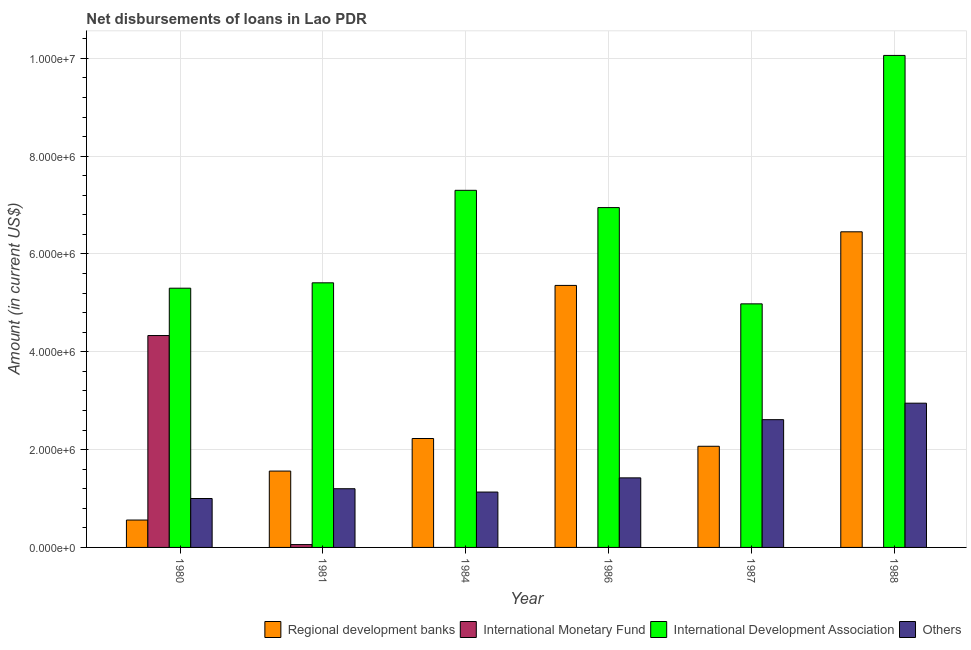In how many cases, is the number of bars for a given year not equal to the number of legend labels?
Your answer should be very brief. 4. What is the amount of loan disimbursed by international monetary fund in 1988?
Offer a very short reply. 0. Across all years, what is the maximum amount of loan disimbursed by regional development banks?
Offer a very short reply. 6.45e+06. Across all years, what is the minimum amount of loan disimbursed by other organisations?
Your response must be concise. 1.00e+06. In which year was the amount of loan disimbursed by international development association maximum?
Your response must be concise. 1988. What is the total amount of loan disimbursed by other organisations in the graph?
Give a very brief answer. 1.03e+07. What is the difference between the amount of loan disimbursed by regional development banks in 1981 and that in 1987?
Keep it short and to the point. -5.07e+05. What is the difference between the amount of loan disimbursed by regional development banks in 1986 and the amount of loan disimbursed by international development association in 1987?
Give a very brief answer. 3.29e+06. What is the average amount of loan disimbursed by regional development banks per year?
Offer a very short reply. 3.04e+06. In the year 1987, what is the difference between the amount of loan disimbursed by regional development banks and amount of loan disimbursed by other organisations?
Offer a terse response. 0. In how many years, is the amount of loan disimbursed by international monetary fund greater than 7600000 US$?
Give a very brief answer. 0. What is the ratio of the amount of loan disimbursed by regional development banks in 1981 to that in 1987?
Keep it short and to the point. 0.75. Is the amount of loan disimbursed by other organisations in 1987 less than that in 1988?
Keep it short and to the point. Yes. What is the difference between the highest and the second highest amount of loan disimbursed by other organisations?
Offer a terse response. 3.37e+05. What is the difference between the highest and the lowest amount of loan disimbursed by international monetary fund?
Your answer should be compact. 4.33e+06. In how many years, is the amount of loan disimbursed by international monetary fund greater than the average amount of loan disimbursed by international monetary fund taken over all years?
Your answer should be very brief. 1. How many bars are there?
Offer a terse response. 20. How many years are there in the graph?
Make the answer very short. 6. What is the difference between two consecutive major ticks on the Y-axis?
Your answer should be very brief. 2.00e+06. Are the values on the major ticks of Y-axis written in scientific E-notation?
Your answer should be compact. Yes. How many legend labels are there?
Keep it short and to the point. 4. How are the legend labels stacked?
Provide a short and direct response. Horizontal. What is the title of the graph?
Make the answer very short. Net disbursements of loans in Lao PDR. Does "Arable land" appear as one of the legend labels in the graph?
Give a very brief answer. No. What is the Amount (in current US$) of Regional development banks in 1980?
Ensure brevity in your answer.  5.60e+05. What is the Amount (in current US$) in International Monetary Fund in 1980?
Make the answer very short. 4.33e+06. What is the Amount (in current US$) in International Development Association in 1980?
Provide a short and direct response. 5.30e+06. What is the Amount (in current US$) in Others in 1980?
Offer a terse response. 1.00e+06. What is the Amount (in current US$) in Regional development banks in 1981?
Give a very brief answer. 1.56e+06. What is the Amount (in current US$) of International Monetary Fund in 1981?
Your answer should be very brief. 5.80e+04. What is the Amount (in current US$) of International Development Association in 1981?
Make the answer very short. 5.41e+06. What is the Amount (in current US$) of Others in 1981?
Ensure brevity in your answer.  1.20e+06. What is the Amount (in current US$) of Regional development banks in 1984?
Provide a short and direct response. 2.23e+06. What is the Amount (in current US$) in International Development Association in 1984?
Make the answer very short. 7.30e+06. What is the Amount (in current US$) in Others in 1984?
Provide a succinct answer. 1.13e+06. What is the Amount (in current US$) of Regional development banks in 1986?
Provide a short and direct response. 5.36e+06. What is the Amount (in current US$) of International Development Association in 1986?
Your response must be concise. 6.95e+06. What is the Amount (in current US$) of Others in 1986?
Offer a terse response. 1.42e+06. What is the Amount (in current US$) in Regional development banks in 1987?
Your answer should be very brief. 2.07e+06. What is the Amount (in current US$) in International Development Association in 1987?
Your answer should be compact. 4.98e+06. What is the Amount (in current US$) in Others in 1987?
Keep it short and to the point. 2.61e+06. What is the Amount (in current US$) of Regional development banks in 1988?
Give a very brief answer. 6.45e+06. What is the Amount (in current US$) of International Development Association in 1988?
Keep it short and to the point. 1.01e+07. What is the Amount (in current US$) in Others in 1988?
Keep it short and to the point. 2.95e+06. Across all years, what is the maximum Amount (in current US$) of Regional development banks?
Ensure brevity in your answer.  6.45e+06. Across all years, what is the maximum Amount (in current US$) of International Monetary Fund?
Your response must be concise. 4.33e+06. Across all years, what is the maximum Amount (in current US$) of International Development Association?
Offer a terse response. 1.01e+07. Across all years, what is the maximum Amount (in current US$) of Others?
Keep it short and to the point. 2.95e+06. Across all years, what is the minimum Amount (in current US$) of Regional development banks?
Your answer should be compact. 5.60e+05. Across all years, what is the minimum Amount (in current US$) in International Monetary Fund?
Your response must be concise. 0. Across all years, what is the minimum Amount (in current US$) in International Development Association?
Your answer should be compact. 4.98e+06. Across all years, what is the minimum Amount (in current US$) of Others?
Your response must be concise. 1.00e+06. What is the total Amount (in current US$) in Regional development banks in the graph?
Ensure brevity in your answer.  1.82e+07. What is the total Amount (in current US$) in International Monetary Fund in the graph?
Provide a short and direct response. 4.39e+06. What is the total Amount (in current US$) of International Development Association in the graph?
Offer a terse response. 4.00e+07. What is the total Amount (in current US$) of Others in the graph?
Your response must be concise. 1.03e+07. What is the difference between the Amount (in current US$) in Regional development banks in 1980 and that in 1981?
Keep it short and to the point. -1.00e+06. What is the difference between the Amount (in current US$) in International Monetary Fund in 1980 and that in 1981?
Offer a very short reply. 4.27e+06. What is the difference between the Amount (in current US$) of Regional development banks in 1980 and that in 1984?
Your response must be concise. -1.67e+06. What is the difference between the Amount (in current US$) in International Development Association in 1980 and that in 1984?
Make the answer very short. -2.00e+06. What is the difference between the Amount (in current US$) of Others in 1980 and that in 1984?
Offer a terse response. -1.32e+05. What is the difference between the Amount (in current US$) of Regional development banks in 1980 and that in 1986?
Your answer should be compact. -4.80e+06. What is the difference between the Amount (in current US$) of International Development Association in 1980 and that in 1986?
Provide a succinct answer. -1.65e+06. What is the difference between the Amount (in current US$) in Others in 1980 and that in 1986?
Provide a short and direct response. -4.22e+05. What is the difference between the Amount (in current US$) in Regional development banks in 1980 and that in 1987?
Give a very brief answer. -1.51e+06. What is the difference between the Amount (in current US$) of Others in 1980 and that in 1987?
Provide a short and direct response. -1.61e+06. What is the difference between the Amount (in current US$) in Regional development banks in 1980 and that in 1988?
Provide a short and direct response. -5.89e+06. What is the difference between the Amount (in current US$) of International Development Association in 1980 and that in 1988?
Your response must be concise. -4.76e+06. What is the difference between the Amount (in current US$) in Others in 1980 and that in 1988?
Provide a succinct answer. -1.95e+06. What is the difference between the Amount (in current US$) in Regional development banks in 1981 and that in 1984?
Your answer should be very brief. -6.66e+05. What is the difference between the Amount (in current US$) in International Development Association in 1981 and that in 1984?
Offer a terse response. -1.89e+06. What is the difference between the Amount (in current US$) in Others in 1981 and that in 1984?
Ensure brevity in your answer.  6.80e+04. What is the difference between the Amount (in current US$) in Regional development banks in 1981 and that in 1986?
Ensure brevity in your answer.  -3.80e+06. What is the difference between the Amount (in current US$) of International Development Association in 1981 and that in 1986?
Your answer should be compact. -1.54e+06. What is the difference between the Amount (in current US$) of Others in 1981 and that in 1986?
Your response must be concise. -2.22e+05. What is the difference between the Amount (in current US$) of Regional development banks in 1981 and that in 1987?
Ensure brevity in your answer.  -5.07e+05. What is the difference between the Amount (in current US$) of International Development Association in 1981 and that in 1987?
Your answer should be compact. 4.30e+05. What is the difference between the Amount (in current US$) in Others in 1981 and that in 1987?
Offer a very short reply. -1.41e+06. What is the difference between the Amount (in current US$) in Regional development banks in 1981 and that in 1988?
Make the answer very short. -4.89e+06. What is the difference between the Amount (in current US$) in International Development Association in 1981 and that in 1988?
Your response must be concise. -4.65e+06. What is the difference between the Amount (in current US$) in Others in 1981 and that in 1988?
Your answer should be compact. -1.75e+06. What is the difference between the Amount (in current US$) of Regional development banks in 1984 and that in 1986?
Provide a short and direct response. -3.13e+06. What is the difference between the Amount (in current US$) in International Development Association in 1984 and that in 1986?
Offer a terse response. 3.53e+05. What is the difference between the Amount (in current US$) in Others in 1984 and that in 1986?
Your answer should be very brief. -2.90e+05. What is the difference between the Amount (in current US$) of Regional development banks in 1984 and that in 1987?
Keep it short and to the point. 1.59e+05. What is the difference between the Amount (in current US$) in International Development Association in 1984 and that in 1987?
Ensure brevity in your answer.  2.32e+06. What is the difference between the Amount (in current US$) in Others in 1984 and that in 1987?
Give a very brief answer. -1.48e+06. What is the difference between the Amount (in current US$) of Regional development banks in 1984 and that in 1988?
Provide a short and direct response. -4.23e+06. What is the difference between the Amount (in current US$) of International Development Association in 1984 and that in 1988?
Your response must be concise. -2.76e+06. What is the difference between the Amount (in current US$) of Others in 1984 and that in 1988?
Provide a succinct answer. -1.82e+06. What is the difference between the Amount (in current US$) in Regional development banks in 1986 and that in 1987?
Your response must be concise. 3.29e+06. What is the difference between the Amount (in current US$) of International Development Association in 1986 and that in 1987?
Ensure brevity in your answer.  1.97e+06. What is the difference between the Amount (in current US$) of Others in 1986 and that in 1987?
Keep it short and to the point. -1.19e+06. What is the difference between the Amount (in current US$) in Regional development banks in 1986 and that in 1988?
Provide a short and direct response. -1.10e+06. What is the difference between the Amount (in current US$) in International Development Association in 1986 and that in 1988?
Make the answer very short. -3.11e+06. What is the difference between the Amount (in current US$) of Others in 1986 and that in 1988?
Give a very brief answer. -1.53e+06. What is the difference between the Amount (in current US$) in Regional development banks in 1987 and that in 1988?
Offer a terse response. -4.38e+06. What is the difference between the Amount (in current US$) of International Development Association in 1987 and that in 1988?
Ensure brevity in your answer.  -5.08e+06. What is the difference between the Amount (in current US$) in Others in 1987 and that in 1988?
Offer a terse response. -3.37e+05. What is the difference between the Amount (in current US$) of Regional development banks in 1980 and the Amount (in current US$) of International Monetary Fund in 1981?
Your response must be concise. 5.02e+05. What is the difference between the Amount (in current US$) of Regional development banks in 1980 and the Amount (in current US$) of International Development Association in 1981?
Provide a short and direct response. -4.85e+06. What is the difference between the Amount (in current US$) in Regional development banks in 1980 and the Amount (in current US$) in Others in 1981?
Keep it short and to the point. -6.40e+05. What is the difference between the Amount (in current US$) of International Monetary Fund in 1980 and the Amount (in current US$) of International Development Association in 1981?
Give a very brief answer. -1.08e+06. What is the difference between the Amount (in current US$) of International Monetary Fund in 1980 and the Amount (in current US$) of Others in 1981?
Give a very brief answer. 3.13e+06. What is the difference between the Amount (in current US$) in International Development Association in 1980 and the Amount (in current US$) in Others in 1981?
Make the answer very short. 4.10e+06. What is the difference between the Amount (in current US$) in Regional development banks in 1980 and the Amount (in current US$) in International Development Association in 1984?
Offer a very short reply. -6.74e+06. What is the difference between the Amount (in current US$) in Regional development banks in 1980 and the Amount (in current US$) in Others in 1984?
Ensure brevity in your answer.  -5.72e+05. What is the difference between the Amount (in current US$) of International Monetary Fund in 1980 and the Amount (in current US$) of International Development Association in 1984?
Your answer should be compact. -2.97e+06. What is the difference between the Amount (in current US$) of International Monetary Fund in 1980 and the Amount (in current US$) of Others in 1984?
Provide a short and direct response. 3.20e+06. What is the difference between the Amount (in current US$) of International Development Association in 1980 and the Amount (in current US$) of Others in 1984?
Give a very brief answer. 4.17e+06. What is the difference between the Amount (in current US$) in Regional development banks in 1980 and the Amount (in current US$) in International Development Association in 1986?
Offer a terse response. -6.39e+06. What is the difference between the Amount (in current US$) of Regional development banks in 1980 and the Amount (in current US$) of Others in 1986?
Ensure brevity in your answer.  -8.62e+05. What is the difference between the Amount (in current US$) of International Monetary Fund in 1980 and the Amount (in current US$) of International Development Association in 1986?
Keep it short and to the point. -2.62e+06. What is the difference between the Amount (in current US$) in International Monetary Fund in 1980 and the Amount (in current US$) in Others in 1986?
Ensure brevity in your answer.  2.91e+06. What is the difference between the Amount (in current US$) in International Development Association in 1980 and the Amount (in current US$) in Others in 1986?
Provide a short and direct response. 3.88e+06. What is the difference between the Amount (in current US$) in Regional development banks in 1980 and the Amount (in current US$) in International Development Association in 1987?
Your answer should be very brief. -4.42e+06. What is the difference between the Amount (in current US$) in Regional development banks in 1980 and the Amount (in current US$) in Others in 1987?
Your answer should be compact. -2.05e+06. What is the difference between the Amount (in current US$) in International Monetary Fund in 1980 and the Amount (in current US$) in International Development Association in 1987?
Your response must be concise. -6.48e+05. What is the difference between the Amount (in current US$) in International Monetary Fund in 1980 and the Amount (in current US$) in Others in 1987?
Your answer should be compact. 1.72e+06. What is the difference between the Amount (in current US$) of International Development Association in 1980 and the Amount (in current US$) of Others in 1987?
Your answer should be compact. 2.69e+06. What is the difference between the Amount (in current US$) in Regional development banks in 1980 and the Amount (in current US$) in International Development Association in 1988?
Your answer should be compact. -9.50e+06. What is the difference between the Amount (in current US$) in Regional development banks in 1980 and the Amount (in current US$) in Others in 1988?
Offer a very short reply. -2.39e+06. What is the difference between the Amount (in current US$) in International Monetary Fund in 1980 and the Amount (in current US$) in International Development Association in 1988?
Provide a short and direct response. -5.73e+06. What is the difference between the Amount (in current US$) in International Monetary Fund in 1980 and the Amount (in current US$) in Others in 1988?
Ensure brevity in your answer.  1.38e+06. What is the difference between the Amount (in current US$) of International Development Association in 1980 and the Amount (in current US$) of Others in 1988?
Your answer should be compact. 2.35e+06. What is the difference between the Amount (in current US$) in Regional development banks in 1981 and the Amount (in current US$) in International Development Association in 1984?
Offer a terse response. -5.74e+06. What is the difference between the Amount (in current US$) in Regional development banks in 1981 and the Amount (in current US$) in Others in 1984?
Offer a very short reply. 4.29e+05. What is the difference between the Amount (in current US$) of International Monetary Fund in 1981 and the Amount (in current US$) of International Development Association in 1984?
Provide a short and direct response. -7.24e+06. What is the difference between the Amount (in current US$) in International Monetary Fund in 1981 and the Amount (in current US$) in Others in 1984?
Provide a short and direct response. -1.07e+06. What is the difference between the Amount (in current US$) of International Development Association in 1981 and the Amount (in current US$) of Others in 1984?
Make the answer very short. 4.28e+06. What is the difference between the Amount (in current US$) of Regional development banks in 1981 and the Amount (in current US$) of International Development Association in 1986?
Keep it short and to the point. -5.39e+06. What is the difference between the Amount (in current US$) in Regional development banks in 1981 and the Amount (in current US$) in Others in 1986?
Keep it short and to the point. 1.39e+05. What is the difference between the Amount (in current US$) of International Monetary Fund in 1981 and the Amount (in current US$) of International Development Association in 1986?
Your answer should be compact. -6.89e+06. What is the difference between the Amount (in current US$) of International Monetary Fund in 1981 and the Amount (in current US$) of Others in 1986?
Your answer should be very brief. -1.36e+06. What is the difference between the Amount (in current US$) in International Development Association in 1981 and the Amount (in current US$) in Others in 1986?
Offer a very short reply. 3.99e+06. What is the difference between the Amount (in current US$) of Regional development banks in 1981 and the Amount (in current US$) of International Development Association in 1987?
Your answer should be very brief. -3.42e+06. What is the difference between the Amount (in current US$) in Regional development banks in 1981 and the Amount (in current US$) in Others in 1987?
Keep it short and to the point. -1.05e+06. What is the difference between the Amount (in current US$) of International Monetary Fund in 1981 and the Amount (in current US$) of International Development Association in 1987?
Your answer should be compact. -4.92e+06. What is the difference between the Amount (in current US$) in International Monetary Fund in 1981 and the Amount (in current US$) in Others in 1987?
Provide a short and direct response. -2.55e+06. What is the difference between the Amount (in current US$) of International Development Association in 1981 and the Amount (in current US$) of Others in 1987?
Offer a terse response. 2.80e+06. What is the difference between the Amount (in current US$) in Regional development banks in 1981 and the Amount (in current US$) in International Development Association in 1988?
Offer a terse response. -8.50e+06. What is the difference between the Amount (in current US$) of Regional development banks in 1981 and the Amount (in current US$) of Others in 1988?
Ensure brevity in your answer.  -1.39e+06. What is the difference between the Amount (in current US$) in International Monetary Fund in 1981 and the Amount (in current US$) in International Development Association in 1988?
Provide a short and direct response. -1.00e+07. What is the difference between the Amount (in current US$) in International Monetary Fund in 1981 and the Amount (in current US$) in Others in 1988?
Give a very brief answer. -2.89e+06. What is the difference between the Amount (in current US$) of International Development Association in 1981 and the Amount (in current US$) of Others in 1988?
Offer a terse response. 2.46e+06. What is the difference between the Amount (in current US$) in Regional development banks in 1984 and the Amount (in current US$) in International Development Association in 1986?
Your answer should be compact. -4.72e+06. What is the difference between the Amount (in current US$) of Regional development banks in 1984 and the Amount (in current US$) of Others in 1986?
Your answer should be very brief. 8.05e+05. What is the difference between the Amount (in current US$) in International Development Association in 1984 and the Amount (in current US$) in Others in 1986?
Your response must be concise. 5.88e+06. What is the difference between the Amount (in current US$) in Regional development banks in 1984 and the Amount (in current US$) in International Development Association in 1987?
Keep it short and to the point. -2.75e+06. What is the difference between the Amount (in current US$) in Regional development banks in 1984 and the Amount (in current US$) in Others in 1987?
Your response must be concise. -3.85e+05. What is the difference between the Amount (in current US$) of International Development Association in 1984 and the Amount (in current US$) of Others in 1987?
Offer a very short reply. 4.69e+06. What is the difference between the Amount (in current US$) in Regional development banks in 1984 and the Amount (in current US$) in International Development Association in 1988?
Your answer should be very brief. -7.83e+06. What is the difference between the Amount (in current US$) in Regional development banks in 1984 and the Amount (in current US$) in Others in 1988?
Provide a succinct answer. -7.22e+05. What is the difference between the Amount (in current US$) of International Development Association in 1984 and the Amount (in current US$) of Others in 1988?
Provide a short and direct response. 4.35e+06. What is the difference between the Amount (in current US$) of Regional development banks in 1986 and the Amount (in current US$) of International Development Association in 1987?
Give a very brief answer. 3.77e+05. What is the difference between the Amount (in current US$) in Regional development banks in 1986 and the Amount (in current US$) in Others in 1987?
Provide a succinct answer. 2.74e+06. What is the difference between the Amount (in current US$) in International Development Association in 1986 and the Amount (in current US$) in Others in 1987?
Your response must be concise. 4.34e+06. What is the difference between the Amount (in current US$) of Regional development banks in 1986 and the Amount (in current US$) of International Development Association in 1988?
Provide a short and direct response. -4.70e+06. What is the difference between the Amount (in current US$) of Regional development banks in 1986 and the Amount (in current US$) of Others in 1988?
Make the answer very short. 2.41e+06. What is the difference between the Amount (in current US$) of International Development Association in 1986 and the Amount (in current US$) of Others in 1988?
Give a very brief answer. 4.00e+06. What is the difference between the Amount (in current US$) in Regional development banks in 1987 and the Amount (in current US$) in International Development Association in 1988?
Give a very brief answer. -7.99e+06. What is the difference between the Amount (in current US$) of Regional development banks in 1987 and the Amount (in current US$) of Others in 1988?
Provide a succinct answer. -8.81e+05. What is the difference between the Amount (in current US$) in International Development Association in 1987 and the Amount (in current US$) in Others in 1988?
Make the answer very short. 2.03e+06. What is the average Amount (in current US$) of Regional development banks per year?
Your answer should be compact. 3.04e+06. What is the average Amount (in current US$) of International Monetary Fund per year?
Your answer should be compact. 7.32e+05. What is the average Amount (in current US$) of International Development Association per year?
Offer a terse response. 6.67e+06. What is the average Amount (in current US$) of Others per year?
Offer a terse response. 1.72e+06. In the year 1980, what is the difference between the Amount (in current US$) in Regional development banks and Amount (in current US$) in International Monetary Fund?
Provide a short and direct response. -3.77e+06. In the year 1980, what is the difference between the Amount (in current US$) in Regional development banks and Amount (in current US$) in International Development Association?
Ensure brevity in your answer.  -4.74e+06. In the year 1980, what is the difference between the Amount (in current US$) of Regional development banks and Amount (in current US$) of Others?
Offer a very short reply. -4.40e+05. In the year 1980, what is the difference between the Amount (in current US$) of International Monetary Fund and Amount (in current US$) of International Development Association?
Your answer should be very brief. -9.68e+05. In the year 1980, what is the difference between the Amount (in current US$) of International Monetary Fund and Amount (in current US$) of Others?
Provide a succinct answer. 3.33e+06. In the year 1980, what is the difference between the Amount (in current US$) of International Development Association and Amount (in current US$) of Others?
Ensure brevity in your answer.  4.30e+06. In the year 1981, what is the difference between the Amount (in current US$) of Regional development banks and Amount (in current US$) of International Monetary Fund?
Keep it short and to the point. 1.50e+06. In the year 1981, what is the difference between the Amount (in current US$) of Regional development banks and Amount (in current US$) of International Development Association?
Provide a short and direct response. -3.85e+06. In the year 1981, what is the difference between the Amount (in current US$) in Regional development banks and Amount (in current US$) in Others?
Provide a succinct answer. 3.61e+05. In the year 1981, what is the difference between the Amount (in current US$) of International Monetary Fund and Amount (in current US$) of International Development Association?
Ensure brevity in your answer.  -5.35e+06. In the year 1981, what is the difference between the Amount (in current US$) of International Monetary Fund and Amount (in current US$) of Others?
Your answer should be compact. -1.14e+06. In the year 1981, what is the difference between the Amount (in current US$) of International Development Association and Amount (in current US$) of Others?
Provide a short and direct response. 4.21e+06. In the year 1984, what is the difference between the Amount (in current US$) of Regional development banks and Amount (in current US$) of International Development Association?
Offer a very short reply. -5.07e+06. In the year 1984, what is the difference between the Amount (in current US$) in Regional development banks and Amount (in current US$) in Others?
Offer a terse response. 1.10e+06. In the year 1984, what is the difference between the Amount (in current US$) in International Development Association and Amount (in current US$) in Others?
Provide a short and direct response. 6.17e+06. In the year 1986, what is the difference between the Amount (in current US$) in Regional development banks and Amount (in current US$) in International Development Association?
Offer a terse response. -1.59e+06. In the year 1986, what is the difference between the Amount (in current US$) of Regional development banks and Amount (in current US$) of Others?
Provide a succinct answer. 3.94e+06. In the year 1986, what is the difference between the Amount (in current US$) in International Development Association and Amount (in current US$) in Others?
Ensure brevity in your answer.  5.53e+06. In the year 1987, what is the difference between the Amount (in current US$) of Regional development banks and Amount (in current US$) of International Development Association?
Provide a succinct answer. -2.91e+06. In the year 1987, what is the difference between the Amount (in current US$) of Regional development banks and Amount (in current US$) of Others?
Make the answer very short. -5.44e+05. In the year 1987, what is the difference between the Amount (in current US$) of International Development Association and Amount (in current US$) of Others?
Your answer should be compact. 2.37e+06. In the year 1988, what is the difference between the Amount (in current US$) in Regional development banks and Amount (in current US$) in International Development Association?
Provide a short and direct response. -3.61e+06. In the year 1988, what is the difference between the Amount (in current US$) of Regional development banks and Amount (in current US$) of Others?
Offer a terse response. 3.50e+06. In the year 1988, what is the difference between the Amount (in current US$) of International Development Association and Amount (in current US$) of Others?
Give a very brief answer. 7.11e+06. What is the ratio of the Amount (in current US$) in Regional development banks in 1980 to that in 1981?
Your answer should be compact. 0.36. What is the ratio of the Amount (in current US$) in International Monetary Fund in 1980 to that in 1981?
Give a very brief answer. 74.69. What is the ratio of the Amount (in current US$) of International Development Association in 1980 to that in 1981?
Provide a succinct answer. 0.98. What is the ratio of the Amount (in current US$) of Regional development banks in 1980 to that in 1984?
Offer a very short reply. 0.25. What is the ratio of the Amount (in current US$) in International Development Association in 1980 to that in 1984?
Offer a terse response. 0.73. What is the ratio of the Amount (in current US$) of Others in 1980 to that in 1984?
Offer a very short reply. 0.88. What is the ratio of the Amount (in current US$) of Regional development banks in 1980 to that in 1986?
Your answer should be very brief. 0.1. What is the ratio of the Amount (in current US$) of International Development Association in 1980 to that in 1986?
Ensure brevity in your answer.  0.76. What is the ratio of the Amount (in current US$) in Others in 1980 to that in 1986?
Give a very brief answer. 0.7. What is the ratio of the Amount (in current US$) of Regional development banks in 1980 to that in 1987?
Your answer should be compact. 0.27. What is the ratio of the Amount (in current US$) in International Development Association in 1980 to that in 1987?
Provide a succinct answer. 1.06. What is the ratio of the Amount (in current US$) of Others in 1980 to that in 1987?
Your answer should be very brief. 0.38. What is the ratio of the Amount (in current US$) of Regional development banks in 1980 to that in 1988?
Ensure brevity in your answer.  0.09. What is the ratio of the Amount (in current US$) of International Development Association in 1980 to that in 1988?
Offer a very short reply. 0.53. What is the ratio of the Amount (in current US$) of Others in 1980 to that in 1988?
Provide a succinct answer. 0.34. What is the ratio of the Amount (in current US$) of Regional development banks in 1981 to that in 1984?
Your answer should be very brief. 0.7. What is the ratio of the Amount (in current US$) in International Development Association in 1981 to that in 1984?
Your answer should be very brief. 0.74. What is the ratio of the Amount (in current US$) in Others in 1981 to that in 1984?
Offer a terse response. 1.06. What is the ratio of the Amount (in current US$) of Regional development banks in 1981 to that in 1986?
Ensure brevity in your answer.  0.29. What is the ratio of the Amount (in current US$) in International Development Association in 1981 to that in 1986?
Provide a succinct answer. 0.78. What is the ratio of the Amount (in current US$) in Others in 1981 to that in 1986?
Your response must be concise. 0.84. What is the ratio of the Amount (in current US$) of Regional development banks in 1981 to that in 1987?
Your answer should be very brief. 0.75. What is the ratio of the Amount (in current US$) of International Development Association in 1981 to that in 1987?
Provide a succinct answer. 1.09. What is the ratio of the Amount (in current US$) in Others in 1981 to that in 1987?
Keep it short and to the point. 0.46. What is the ratio of the Amount (in current US$) in Regional development banks in 1981 to that in 1988?
Your answer should be very brief. 0.24. What is the ratio of the Amount (in current US$) of International Development Association in 1981 to that in 1988?
Offer a very short reply. 0.54. What is the ratio of the Amount (in current US$) of Others in 1981 to that in 1988?
Your answer should be very brief. 0.41. What is the ratio of the Amount (in current US$) in Regional development banks in 1984 to that in 1986?
Ensure brevity in your answer.  0.42. What is the ratio of the Amount (in current US$) in International Development Association in 1984 to that in 1986?
Offer a very short reply. 1.05. What is the ratio of the Amount (in current US$) of Others in 1984 to that in 1986?
Give a very brief answer. 0.8. What is the ratio of the Amount (in current US$) of Regional development banks in 1984 to that in 1987?
Offer a very short reply. 1.08. What is the ratio of the Amount (in current US$) in International Development Association in 1984 to that in 1987?
Offer a very short reply. 1.47. What is the ratio of the Amount (in current US$) of Others in 1984 to that in 1987?
Provide a succinct answer. 0.43. What is the ratio of the Amount (in current US$) of Regional development banks in 1984 to that in 1988?
Provide a succinct answer. 0.35. What is the ratio of the Amount (in current US$) in International Development Association in 1984 to that in 1988?
Keep it short and to the point. 0.73. What is the ratio of the Amount (in current US$) of Others in 1984 to that in 1988?
Your answer should be very brief. 0.38. What is the ratio of the Amount (in current US$) of Regional development banks in 1986 to that in 1987?
Offer a very short reply. 2.59. What is the ratio of the Amount (in current US$) in International Development Association in 1986 to that in 1987?
Provide a short and direct response. 1.4. What is the ratio of the Amount (in current US$) in Others in 1986 to that in 1987?
Provide a succinct answer. 0.54. What is the ratio of the Amount (in current US$) in Regional development banks in 1986 to that in 1988?
Your answer should be compact. 0.83. What is the ratio of the Amount (in current US$) of International Development Association in 1986 to that in 1988?
Ensure brevity in your answer.  0.69. What is the ratio of the Amount (in current US$) of Others in 1986 to that in 1988?
Ensure brevity in your answer.  0.48. What is the ratio of the Amount (in current US$) in Regional development banks in 1987 to that in 1988?
Ensure brevity in your answer.  0.32. What is the ratio of the Amount (in current US$) of International Development Association in 1987 to that in 1988?
Keep it short and to the point. 0.5. What is the ratio of the Amount (in current US$) in Others in 1987 to that in 1988?
Offer a very short reply. 0.89. What is the difference between the highest and the second highest Amount (in current US$) in Regional development banks?
Your answer should be compact. 1.10e+06. What is the difference between the highest and the second highest Amount (in current US$) in International Development Association?
Offer a terse response. 2.76e+06. What is the difference between the highest and the second highest Amount (in current US$) in Others?
Offer a terse response. 3.37e+05. What is the difference between the highest and the lowest Amount (in current US$) of Regional development banks?
Your answer should be compact. 5.89e+06. What is the difference between the highest and the lowest Amount (in current US$) in International Monetary Fund?
Your response must be concise. 4.33e+06. What is the difference between the highest and the lowest Amount (in current US$) of International Development Association?
Keep it short and to the point. 5.08e+06. What is the difference between the highest and the lowest Amount (in current US$) in Others?
Provide a succinct answer. 1.95e+06. 